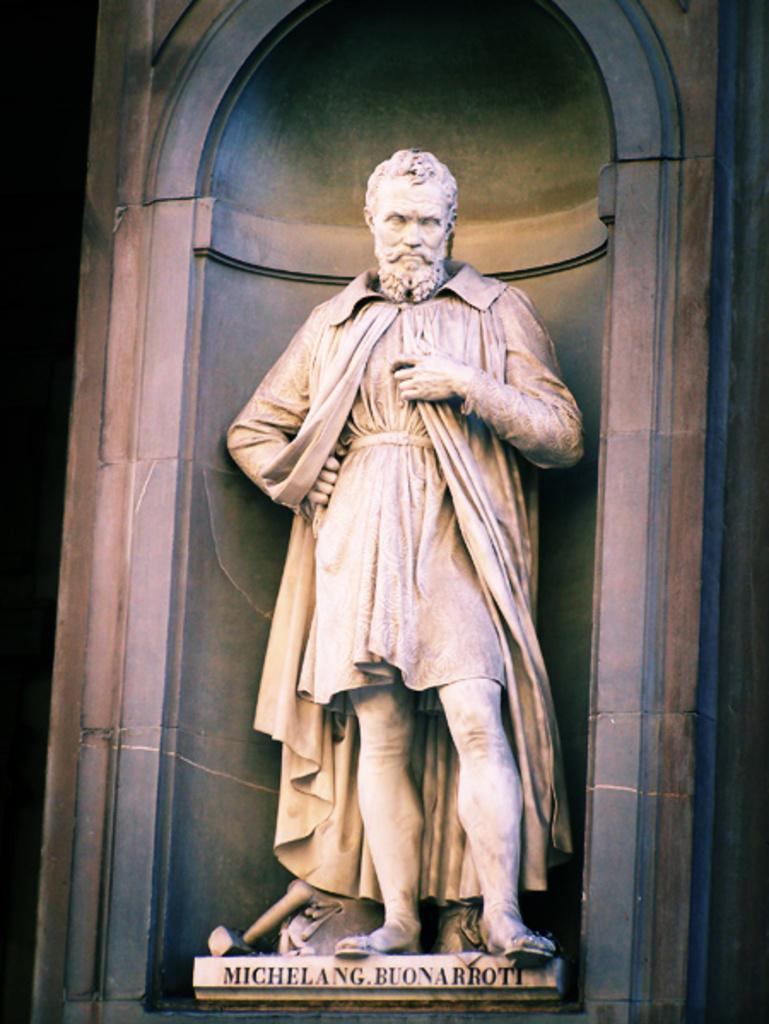What is the main subject in the middle of the image? There is a statue of a person in the image. Where is the statue located in relation to the image? The statue is in the middle of the image. What can be seen in the background of the image? There is a wall in the background of the image. What information is provided at the bottom of the image? There is text written at the bottom of the image. Can you see a heart-shaped lake near the statue in the image? There is no lake, heart-shaped or otherwise, present in the image. 